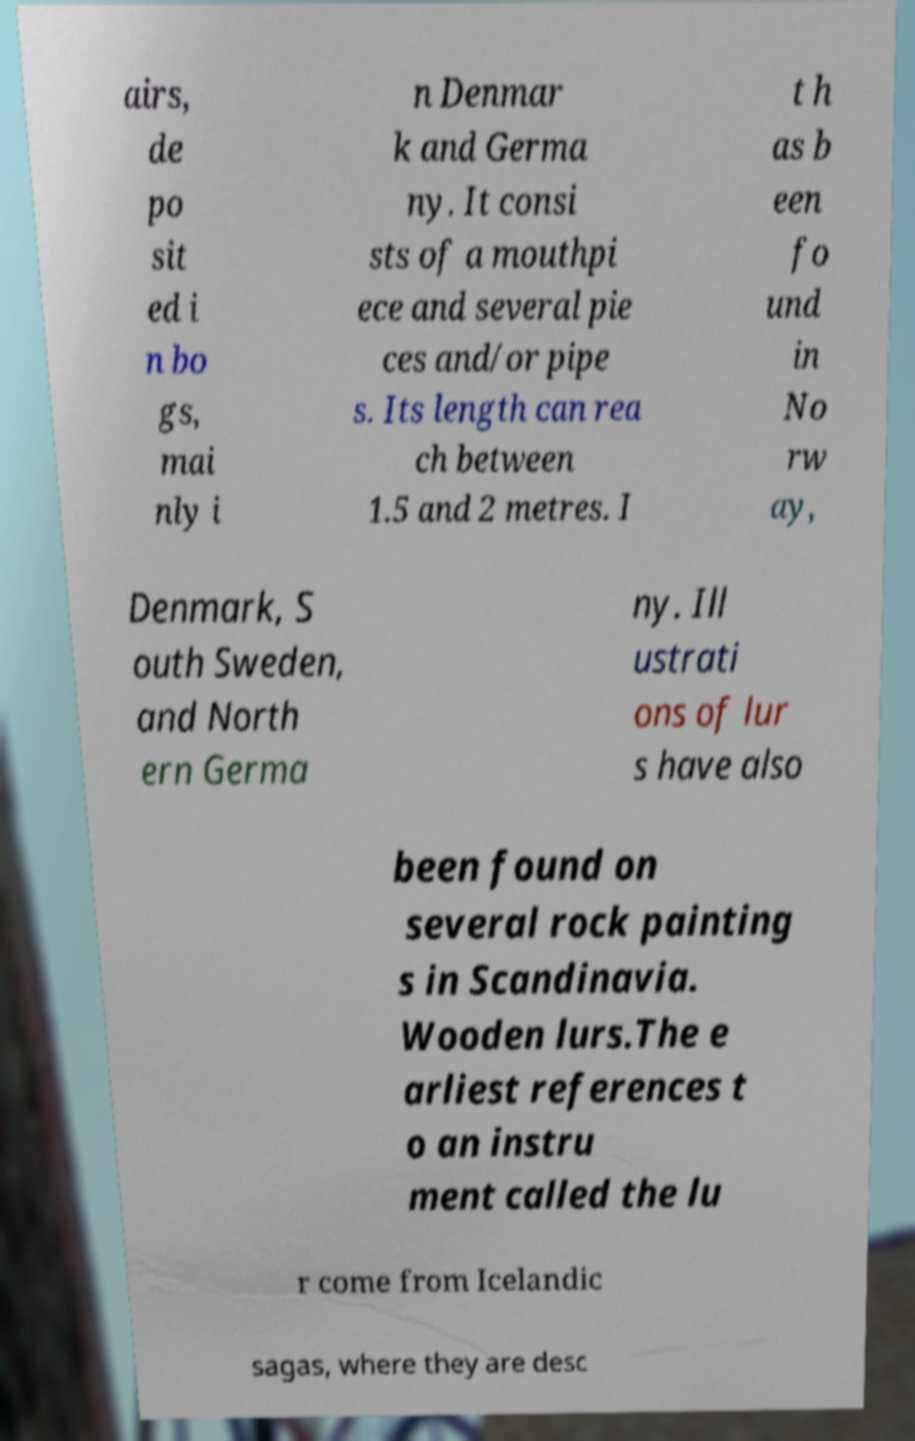Could you extract and type out the text from this image? airs, de po sit ed i n bo gs, mai nly i n Denmar k and Germa ny. It consi sts of a mouthpi ece and several pie ces and/or pipe s. Its length can rea ch between 1.5 and 2 metres. I t h as b een fo und in No rw ay, Denmark, S outh Sweden, and North ern Germa ny. Ill ustrati ons of lur s have also been found on several rock painting s in Scandinavia. Wooden lurs.The e arliest references t o an instru ment called the lu r come from Icelandic sagas, where they are desc 